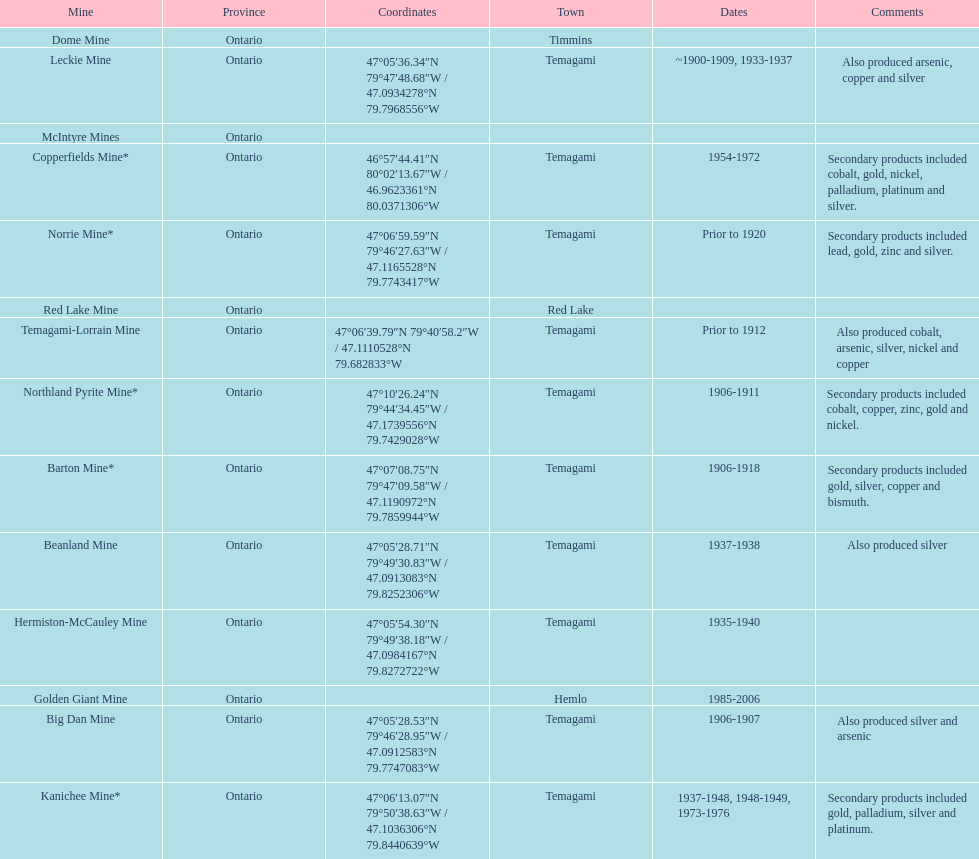Would you mind parsing the complete table? {'header': ['Mine', 'Province', 'Coordinates', 'Town', 'Dates', 'Comments'], 'rows': [['Dome Mine', 'Ontario', '', 'Timmins', '', ''], ['Leckie Mine', 'Ontario', '47°05′36.34″N 79°47′48.68″W\ufeff / \ufeff47.0934278°N 79.7968556°W', 'Temagami', '~1900-1909, 1933-1937', 'Also produced arsenic, copper and silver'], ['McIntyre Mines', 'Ontario', '', '', '', ''], ['Copperfields Mine*', 'Ontario', '46°57′44.41″N 80°02′13.67″W\ufeff / \ufeff46.9623361°N 80.0371306°W', 'Temagami', '1954-1972', 'Secondary products included cobalt, gold, nickel, palladium, platinum and silver.'], ['Norrie Mine*', 'Ontario', '47°06′59.59″N 79°46′27.63″W\ufeff / \ufeff47.1165528°N 79.7743417°W', 'Temagami', 'Prior to 1920', 'Secondary products included lead, gold, zinc and silver.'], ['Red Lake Mine', 'Ontario', '', 'Red Lake', '', ''], ['Temagami-Lorrain Mine', 'Ontario', '47°06′39.79″N 79°40′58.2″W\ufeff / \ufeff47.1110528°N 79.682833°W', 'Temagami', 'Prior to 1912', 'Also produced cobalt, arsenic, silver, nickel and copper'], ['Northland Pyrite Mine*', 'Ontario', '47°10′26.24″N 79°44′34.45″W\ufeff / \ufeff47.1739556°N 79.7429028°W', 'Temagami', '1906-1911', 'Secondary products included cobalt, copper, zinc, gold and nickel.'], ['Barton Mine*', 'Ontario', '47°07′08.75″N 79°47′09.58″W\ufeff / \ufeff47.1190972°N 79.7859944°W', 'Temagami', '1906-1918', 'Secondary products included gold, silver, copper and bismuth.'], ['Beanland Mine', 'Ontario', '47°05′28.71″N 79°49′30.83″W\ufeff / \ufeff47.0913083°N 79.8252306°W', 'Temagami', '1937-1938', 'Also produced silver'], ['Hermiston-McCauley Mine', 'Ontario', '47°05′54.30″N 79°49′38.18″W\ufeff / \ufeff47.0984167°N 79.8272722°W', 'Temagami', '1935-1940', ''], ['Golden Giant Mine', 'Ontario', '', 'Hemlo', '1985-2006', ''], ['Big Dan Mine', 'Ontario', '47°05′28.53″N 79°46′28.95″W\ufeff / \ufeff47.0912583°N 79.7747083°W', 'Temagami', '1906-1907', 'Also produced silver and arsenic'], ['Kanichee Mine*', 'Ontario', '47°06′13.07″N 79°50′38.63″W\ufeff / \ufeff47.1036306°N 79.8440639°W', 'Temagami', '1937-1948, 1948-1949, 1973-1976', 'Secondary products included gold, palladium, silver and platinum.']]} What is the frequency of temagami being mentioned on the list? 10. 